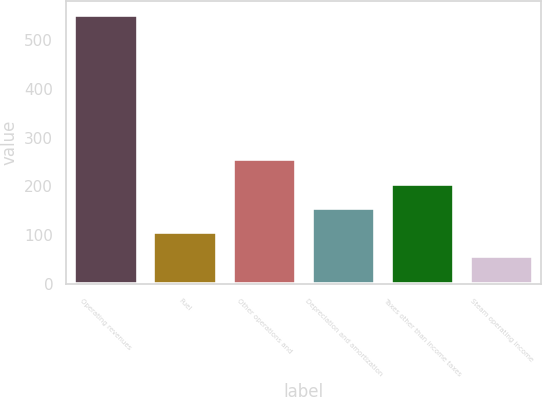<chart> <loc_0><loc_0><loc_500><loc_500><bar_chart><fcel>Operating revenues<fcel>Fuel<fcel>Other operations and<fcel>Depreciation and amortization<fcel>Taxes other than income taxes<fcel>Steam operating income<nl><fcel>551<fcel>107.3<fcel>255.2<fcel>156.6<fcel>205.9<fcel>58<nl></chart> 